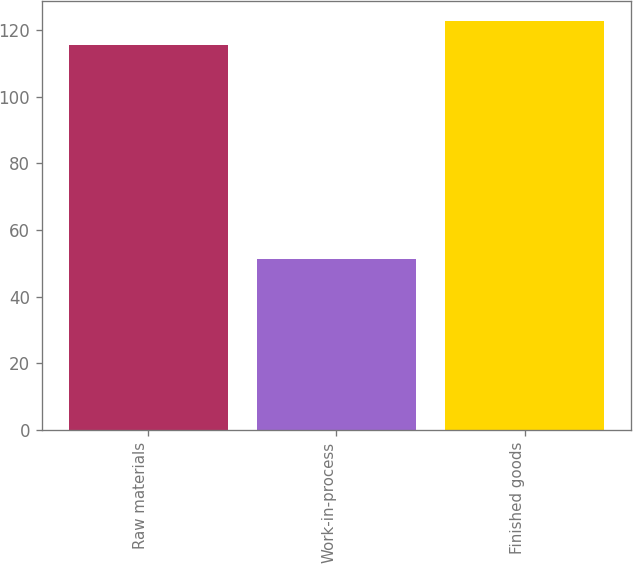<chart> <loc_0><loc_0><loc_500><loc_500><bar_chart><fcel>Raw materials<fcel>Work-in-process<fcel>Finished goods<nl><fcel>115.6<fcel>51.2<fcel>122.74<nl></chart> 